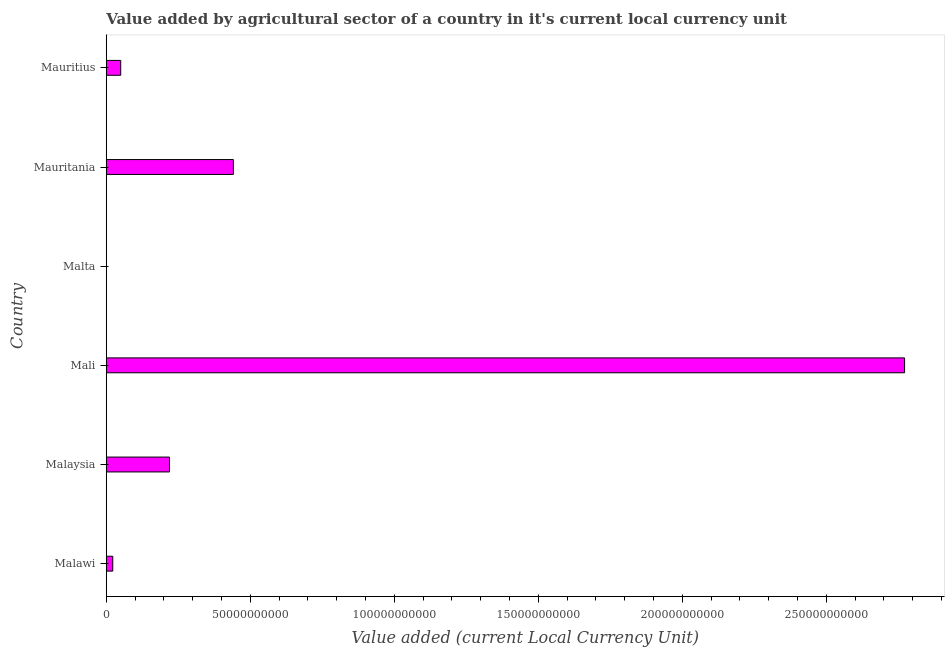Does the graph contain any zero values?
Your answer should be compact. No. What is the title of the graph?
Offer a very short reply. Value added by agricultural sector of a country in it's current local currency unit. What is the label or title of the X-axis?
Make the answer very short. Value added (current Local Currency Unit). What is the value added by agriculture sector in Mauritania?
Ensure brevity in your answer.  4.41e+1. Across all countries, what is the maximum value added by agriculture sector?
Your answer should be compact. 2.77e+11. Across all countries, what is the minimum value added by agriculture sector?
Offer a terse response. 6.20e+07. In which country was the value added by agriculture sector maximum?
Your answer should be compact. Mali. In which country was the value added by agriculture sector minimum?
Provide a short and direct response. Malta. What is the sum of the value added by agriculture sector?
Offer a very short reply. 3.51e+11. What is the difference between the value added by agriculture sector in Mali and Mauritius?
Give a very brief answer. 2.72e+11. What is the average value added by agriculture sector per country?
Offer a very short reply. 5.84e+1. What is the median value added by agriculture sector?
Give a very brief answer. 1.35e+1. In how many countries, is the value added by agriculture sector greater than 50000000000 LCU?
Your response must be concise. 1. What is the ratio of the value added by agriculture sector in Malaysia to that in Mauritius?
Keep it short and to the point. 4.37. Is the value added by agriculture sector in Malaysia less than that in Mauritius?
Provide a succinct answer. No. Is the difference between the value added by agriculture sector in Mauritania and Mauritius greater than the difference between any two countries?
Keep it short and to the point. No. What is the difference between the highest and the second highest value added by agriculture sector?
Provide a short and direct response. 2.33e+11. What is the difference between the highest and the lowest value added by agriculture sector?
Offer a terse response. 2.77e+11. In how many countries, is the value added by agriculture sector greater than the average value added by agriculture sector taken over all countries?
Ensure brevity in your answer.  1. What is the difference between two consecutive major ticks on the X-axis?
Your response must be concise. 5.00e+1. What is the Value added (current Local Currency Unit) in Malawi?
Give a very brief answer. 2.27e+09. What is the Value added (current Local Currency Unit) of Malaysia?
Your answer should be very brief. 2.20e+1. What is the Value added (current Local Currency Unit) of Mali?
Provide a short and direct response. 2.77e+11. What is the Value added (current Local Currency Unit) of Malta?
Your response must be concise. 6.20e+07. What is the Value added (current Local Currency Unit) of Mauritania?
Your answer should be compact. 4.41e+1. What is the Value added (current Local Currency Unit) in Mauritius?
Make the answer very short. 5.02e+09. What is the difference between the Value added (current Local Currency Unit) in Malawi and Malaysia?
Offer a terse response. -1.97e+1. What is the difference between the Value added (current Local Currency Unit) in Malawi and Mali?
Your answer should be very brief. -2.75e+11. What is the difference between the Value added (current Local Currency Unit) in Malawi and Malta?
Keep it short and to the point. 2.20e+09. What is the difference between the Value added (current Local Currency Unit) in Malawi and Mauritania?
Offer a very short reply. -4.19e+1. What is the difference between the Value added (current Local Currency Unit) in Malawi and Mauritius?
Offer a terse response. -2.76e+09. What is the difference between the Value added (current Local Currency Unit) in Malaysia and Mali?
Ensure brevity in your answer.  -2.55e+11. What is the difference between the Value added (current Local Currency Unit) in Malaysia and Malta?
Ensure brevity in your answer.  2.19e+1. What is the difference between the Value added (current Local Currency Unit) in Malaysia and Mauritania?
Your response must be concise. -2.22e+1. What is the difference between the Value added (current Local Currency Unit) in Malaysia and Mauritius?
Give a very brief answer. 1.69e+1. What is the difference between the Value added (current Local Currency Unit) in Mali and Malta?
Offer a terse response. 2.77e+11. What is the difference between the Value added (current Local Currency Unit) in Mali and Mauritania?
Your answer should be compact. 2.33e+11. What is the difference between the Value added (current Local Currency Unit) in Mali and Mauritius?
Provide a short and direct response. 2.72e+11. What is the difference between the Value added (current Local Currency Unit) in Malta and Mauritania?
Provide a succinct answer. -4.41e+1. What is the difference between the Value added (current Local Currency Unit) in Malta and Mauritius?
Offer a very short reply. -4.96e+09. What is the difference between the Value added (current Local Currency Unit) in Mauritania and Mauritius?
Your answer should be compact. 3.91e+1. What is the ratio of the Value added (current Local Currency Unit) in Malawi to that in Malaysia?
Your answer should be compact. 0.1. What is the ratio of the Value added (current Local Currency Unit) in Malawi to that in Mali?
Give a very brief answer. 0.01. What is the ratio of the Value added (current Local Currency Unit) in Malawi to that in Malta?
Offer a terse response. 36.51. What is the ratio of the Value added (current Local Currency Unit) in Malawi to that in Mauritania?
Offer a very short reply. 0.05. What is the ratio of the Value added (current Local Currency Unit) in Malawi to that in Mauritius?
Your answer should be very brief. 0.45. What is the ratio of the Value added (current Local Currency Unit) in Malaysia to that in Mali?
Your answer should be very brief. 0.08. What is the ratio of the Value added (current Local Currency Unit) in Malaysia to that in Malta?
Your response must be concise. 353.9. What is the ratio of the Value added (current Local Currency Unit) in Malaysia to that in Mauritania?
Make the answer very short. 0.5. What is the ratio of the Value added (current Local Currency Unit) in Malaysia to that in Mauritius?
Make the answer very short. 4.37. What is the ratio of the Value added (current Local Currency Unit) in Mali to that in Malta?
Provide a succinct answer. 4467.67. What is the ratio of the Value added (current Local Currency Unit) in Mali to that in Mauritania?
Make the answer very short. 6.28. What is the ratio of the Value added (current Local Currency Unit) in Mali to that in Mauritius?
Keep it short and to the point. 55.17. What is the ratio of the Value added (current Local Currency Unit) in Malta to that in Mauritania?
Your response must be concise. 0. What is the ratio of the Value added (current Local Currency Unit) in Malta to that in Mauritius?
Provide a succinct answer. 0.01. What is the ratio of the Value added (current Local Currency Unit) in Mauritania to that in Mauritius?
Keep it short and to the point. 8.79. 